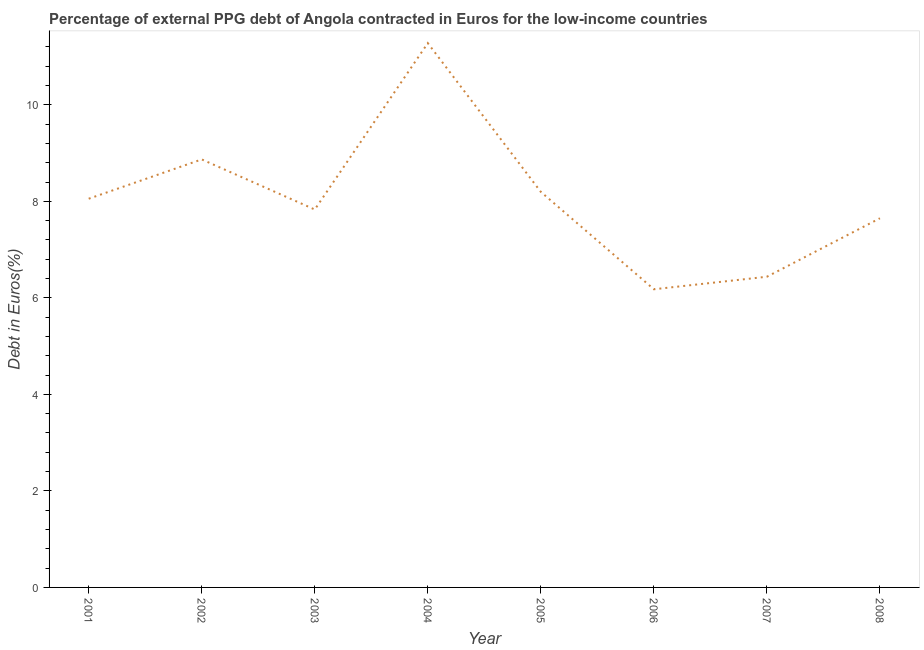What is the currency composition of ppg debt in 2007?
Give a very brief answer. 6.44. Across all years, what is the maximum currency composition of ppg debt?
Your response must be concise. 11.28. Across all years, what is the minimum currency composition of ppg debt?
Ensure brevity in your answer.  6.18. In which year was the currency composition of ppg debt maximum?
Your answer should be compact. 2004. In which year was the currency composition of ppg debt minimum?
Provide a short and direct response. 2006. What is the sum of the currency composition of ppg debt?
Your answer should be very brief. 64.49. What is the difference between the currency composition of ppg debt in 2002 and 2004?
Offer a terse response. -2.41. What is the average currency composition of ppg debt per year?
Offer a very short reply. 8.06. What is the median currency composition of ppg debt?
Give a very brief answer. 7.94. In how many years, is the currency composition of ppg debt greater than 5.6 %?
Keep it short and to the point. 8. Do a majority of the years between 2006 and 2008 (inclusive) have currency composition of ppg debt greater than 10.8 %?
Make the answer very short. No. What is the ratio of the currency composition of ppg debt in 2001 to that in 2004?
Give a very brief answer. 0.71. Is the currency composition of ppg debt in 2005 less than that in 2007?
Keep it short and to the point. No. What is the difference between the highest and the second highest currency composition of ppg debt?
Offer a very short reply. 2.41. What is the difference between the highest and the lowest currency composition of ppg debt?
Your answer should be compact. 5.1. Does the currency composition of ppg debt monotonically increase over the years?
Keep it short and to the point. No. How many lines are there?
Your answer should be compact. 1. What is the difference between two consecutive major ticks on the Y-axis?
Your response must be concise. 2. Does the graph contain any zero values?
Offer a very short reply. No. What is the title of the graph?
Your answer should be very brief. Percentage of external PPG debt of Angola contracted in Euros for the low-income countries. What is the label or title of the X-axis?
Your response must be concise. Year. What is the label or title of the Y-axis?
Provide a short and direct response. Debt in Euros(%). What is the Debt in Euros(%) of 2001?
Provide a short and direct response. 8.05. What is the Debt in Euros(%) of 2002?
Make the answer very short. 8.87. What is the Debt in Euros(%) of 2003?
Provide a short and direct response. 7.83. What is the Debt in Euros(%) in 2004?
Your answer should be compact. 11.28. What is the Debt in Euros(%) in 2005?
Provide a succinct answer. 8.2. What is the Debt in Euros(%) of 2006?
Keep it short and to the point. 6.18. What is the Debt in Euros(%) of 2007?
Your answer should be compact. 6.44. What is the Debt in Euros(%) of 2008?
Your answer should be very brief. 7.65. What is the difference between the Debt in Euros(%) in 2001 and 2002?
Your response must be concise. -0.81. What is the difference between the Debt in Euros(%) in 2001 and 2003?
Your response must be concise. 0.22. What is the difference between the Debt in Euros(%) in 2001 and 2004?
Ensure brevity in your answer.  -3.22. What is the difference between the Debt in Euros(%) in 2001 and 2005?
Offer a terse response. -0.14. What is the difference between the Debt in Euros(%) in 2001 and 2006?
Provide a short and direct response. 1.88. What is the difference between the Debt in Euros(%) in 2001 and 2007?
Your response must be concise. 1.62. What is the difference between the Debt in Euros(%) in 2001 and 2008?
Keep it short and to the point. 0.4. What is the difference between the Debt in Euros(%) in 2002 and 2003?
Your answer should be very brief. 1.04. What is the difference between the Debt in Euros(%) in 2002 and 2004?
Provide a succinct answer. -2.41. What is the difference between the Debt in Euros(%) in 2002 and 2005?
Ensure brevity in your answer.  0.67. What is the difference between the Debt in Euros(%) in 2002 and 2006?
Give a very brief answer. 2.69. What is the difference between the Debt in Euros(%) in 2002 and 2007?
Your response must be concise. 2.43. What is the difference between the Debt in Euros(%) in 2002 and 2008?
Your response must be concise. 1.22. What is the difference between the Debt in Euros(%) in 2003 and 2004?
Offer a very short reply. -3.45. What is the difference between the Debt in Euros(%) in 2003 and 2005?
Give a very brief answer. -0.37. What is the difference between the Debt in Euros(%) in 2003 and 2006?
Offer a very short reply. 1.65. What is the difference between the Debt in Euros(%) in 2003 and 2007?
Offer a very short reply. 1.39. What is the difference between the Debt in Euros(%) in 2003 and 2008?
Offer a very short reply. 0.18. What is the difference between the Debt in Euros(%) in 2004 and 2005?
Keep it short and to the point. 3.08. What is the difference between the Debt in Euros(%) in 2004 and 2006?
Keep it short and to the point. 5.1. What is the difference between the Debt in Euros(%) in 2004 and 2007?
Your response must be concise. 4.84. What is the difference between the Debt in Euros(%) in 2004 and 2008?
Your response must be concise. 3.63. What is the difference between the Debt in Euros(%) in 2005 and 2006?
Your answer should be compact. 2.02. What is the difference between the Debt in Euros(%) in 2005 and 2007?
Keep it short and to the point. 1.76. What is the difference between the Debt in Euros(%) in 2005 and 2008?
Offer a very short reply. 0.55. What is the difference between the Debt in Euros(%) in 2006 and 2007?
Your response must be concise. -0.26. What is the difference between the Debt in Euros(%) in 2006 and 2008?
Keep it short and to the point. -1.47. What is the difference between the Debt in Euros(%) in 2007 and 2008?
Your response must be concise. -1.21. What is the ratio of the Debt in Euros(%) in 2001 to that in 2002?
Your response must be concise. 0.91. What is the ratio of the Debt in Euros(%) in 2001 to that in 2004?
Offer a terse response. 0.71. What is the ratio of the Debt in Euros(%) in 2001 to that in 2005?
Keep it short and to the point. 0.98. What is the ratio of the Debt in Euros(%) in 2001 to that in 2006?
Your answer should be very brief. 1.3. What is the ratio of the Debt in Euros(%) in 2001 to that in 2007?
Your answer should be compact. 1.25. What is the ratio of the Debt in Euros(%) in 2001 to that in 2008?
Offer a terse response. 1.05. What is the ratio of the Debt in Euros(%) in 2002 to that in 2003?
Keep it short and to the point. 1.13. What is the ratio of the Debt in Euros(%) in 2002 to that in 2004?
Make the answer very short. 0.79. What is the ratio of the Debt in Euros(%) in 2002 to that in 2005?
Ensure brevity in your answer.  1.08. What is the ratio of the Debt in Euros(%) in 2002 to that in 2006?
Give a very brief answer. 1.44. What is the ratio of the Debt in Euros(%) in 2002 to that in 2007?
Make the answer very short. 1.38. What is the ratio of the Debt in Euros(%) in 2002 to that in 2008?
Provide a succinct answer. 1.16. What is the ratio of the Debt in Euros(%) in 2003 to that in 2004?
Your response must be concise. 0.69. What is the ratio of the Debt in Euros(%) in 2003 to that in 2005?
Keep it short and to the point. 0.95. What is the ratio of the Debt in Euros(%) in 2003 to that in 2006?
Keep it short and to the point. 1.27. What is the ratio of the Debt in Euros(%) in 2003 to that in 2007?
Offer a terse response. 1.22. What is the ratio of the Debt in Euros(%) in 2004 to that in 2005?
Offer a very short reply. 1.38. What is the ratio of the Debt in Euros(%) in 2004 to that in 2006?
Your answer should be compact. 1.83. What is the ratio of the Debt in Euros(%) in 2004 to that in 2007?
Provide a succinct answer. 1.75. What is the ratio of the Debt in Euros(%) in 2004 to that in 2008?
Provide a short and direct response. 1.47. What is the ratio of the Debt in Euros(%) in 2005 to that in 2006?
Your response must be concise. 1.33. What is the ratio of the Debt in Euros(%) in 2005 to that in 2007?
Provide a short and direct response. 1.27. What is the ratio of the Debt in Euros(%) in 2005 to that in 2008?
Make the answer very short. 1.07. What is the ratio of the Debt in Euros(%) in 2006 to that in 2008?
Your answer should be compact. 0.81. What is the ratio of the Debt in Euros(%) in 2007 to that in 2008?
Offer a terse response. 0.84. 